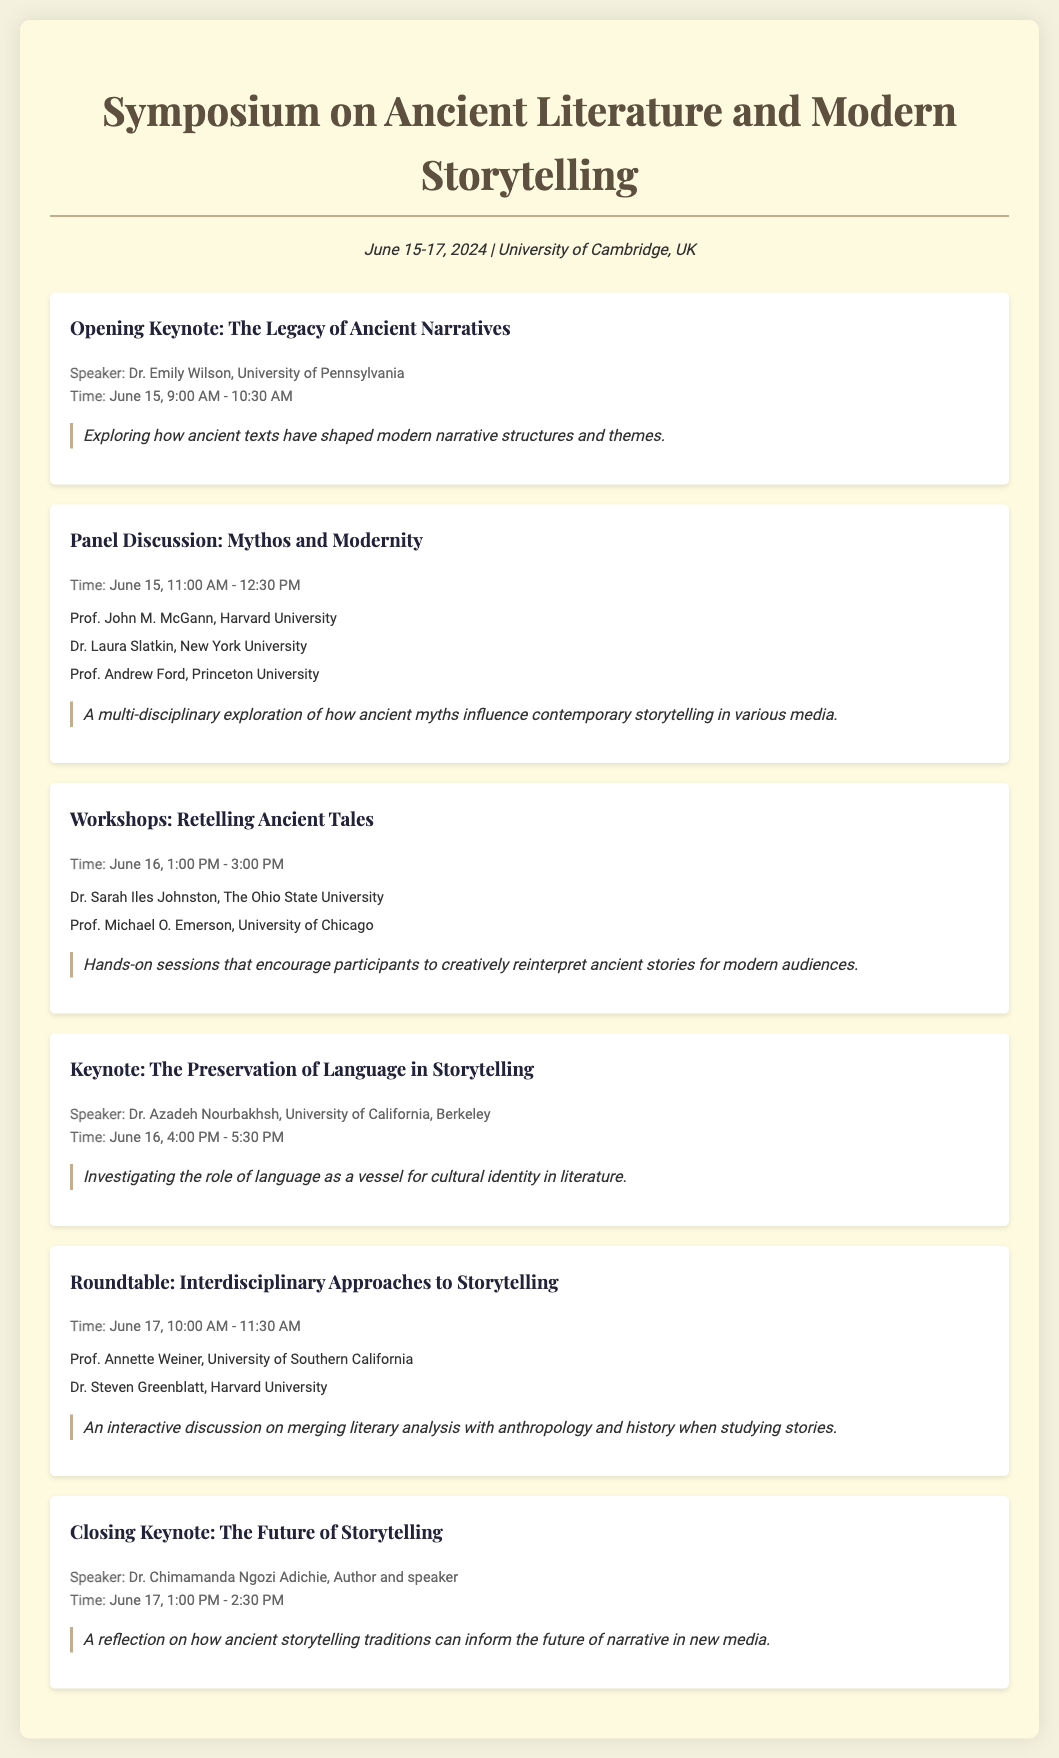What is the date of the symposium? The date of the symposium is mentioned in the document as June 15-17, 2024.
Answer: June 15-17, 2024 Who is the speaker for the opening keynote? The document lists Dr. Emily Wilson as the speaker for the opening keynote session.
Answer: Dr. Emily Wilson What time does the panel discussion start? The document specifies the starting time of the panel discussion as June 15, 11:00 AM.
Answer: 11:00 AM Which university does Dr. Azadeh Nourbakhsh represent? The document indicates that Dr. Azadeh Nourbakhsh is affiliated with the University of California, Berkeley.
Answer: University of California, Berkeley How many workshops are mentioned in the document? The document details one workshop session titled "Workshops: Retelling Ancient Tales."
Answer: One What is the focus of the closing keynote? The document states that the closing keynote focuses on how ancient storytelling traditions can inform future narratives.
Answer: The Future of Storytelling What type of session is scheduled for June 16 at 1:00 PM? The document describes a hands-on workshop session scheduled for that date and time.
Answer: Workshops Who are the speakers in the roundtable session? The document names Prof. Annette Weiner and Dr. Steven Greenblatt as speakers in the roundtable session.
Answer: Prof. Annette Weiner, Dr. Steven Greenblatt 